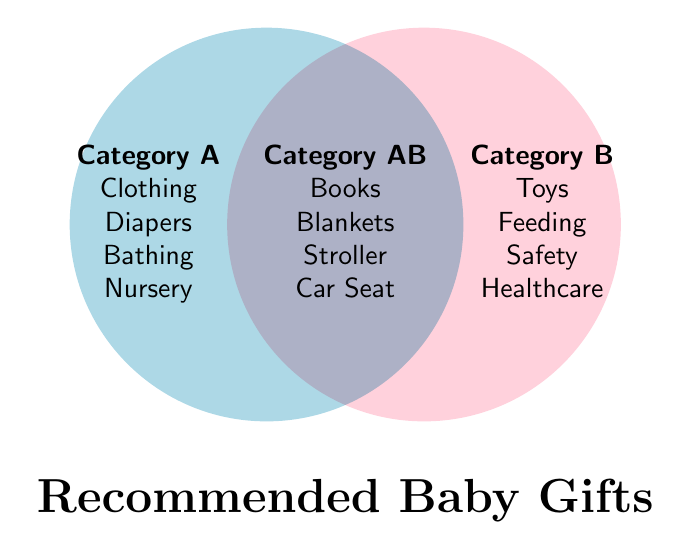What is the title of the figure? The title can be found below the Venn Diagram in a bold and large font.
Answer: Recommended Baby Gifts Which category includes both 'Clothing' and 'Nursery'? Both 'Clothing' and 'Nursery' are listed in Category A, which is found in the left circle of the diagram.
Answer: Category A Where would 'Blankets' fit in the Venn Diagram? 'Blankets' is listed in the intersection area of the diagram, which is Category AB.
Answer: Category AB How many items are specific to Category B? Category B contains four items: 'Toys', 'Feeding', 'Safety', and 'Healthcare'.
Answer: Four Is 'Stroller' exclusively in Category A? No, 'Stroller' is in the overlapping section, Category AB, indicating it fits both Category A and B.
Answer: No List the items in Category A but not in Category AB. Category A (left circle) minus entries in Category AB (overlapping section) includes 'Clothing', 'Diapers', 'Bathing', and 'Nursery'.
Answer: Clothing, Diapers, Bathing, Nursery Which category has 'Healthcare'? 'Healthcare' is found in Category B on the right side of the circle.
Answer: Category B Compare the quantity of items in Category A and Category B? Category A and Category B both have four items each.
Answer: Equal How many unique items are there in the entire diagram? Add items from Category A, Category B then subtract those in Category AB to avoid double counting: (4 from A) + (4 from B) - (4 in AB) = 4 + 4 - 4 = 4. Total number is 8 unique items.
Answer: 8 